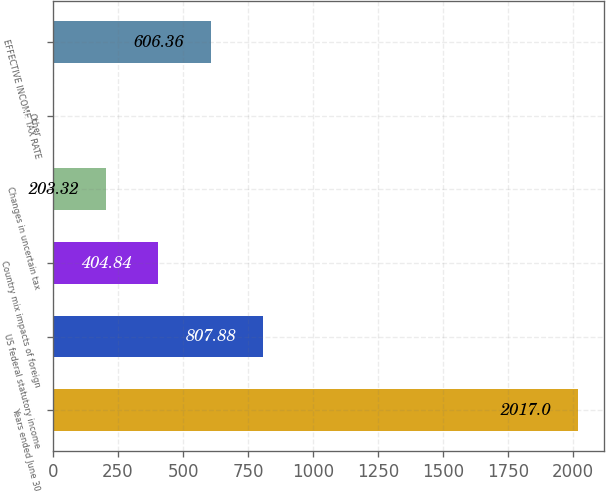Convert chart to OTSL. <chart><loc_0><loc_0><loc_500><loc_500><bar_chart><fcel>Years ended June 30<fcel>US federal statutory income<fcel>Country mix impacts of foreign<fcel>Changes in uncertain tax<fcel>Other<fcel>EFFECTIVE INCOME TAX RATE<nl><fcel>2017<fcel>807.88<fcel>404.84<fcel>203.32<fcel>1.8<fcel>606.36<nl></chart> 